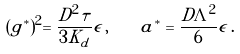Convert formula to latex. <formula><loc_0><loc_0><loc_500><loc_500>( g ^ { * } ) ^ { 2 } = \frac { D ^ { 2 } \tau } { 3 K _ { d } } \epsilon \, , \quad a ^ { * } = \frac { D \Lambda ^ { 2 } } { 6 } \epsilon \, .</formula> 